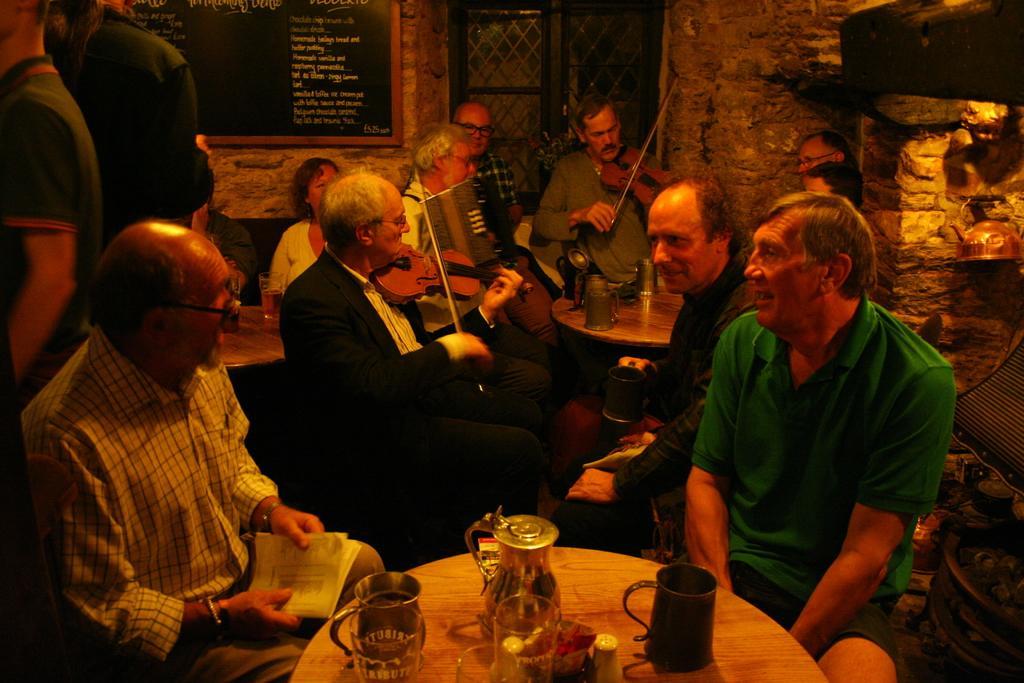Describe this image in one or two sentences. The photo is clicked inside a room. There are many people sitting on chairs. There are table on the table there are jug,glasses,mug. This person is playing violin along with this person. here people are talking. Here people are standing. In the background there is a blackboard, a window and wall. 